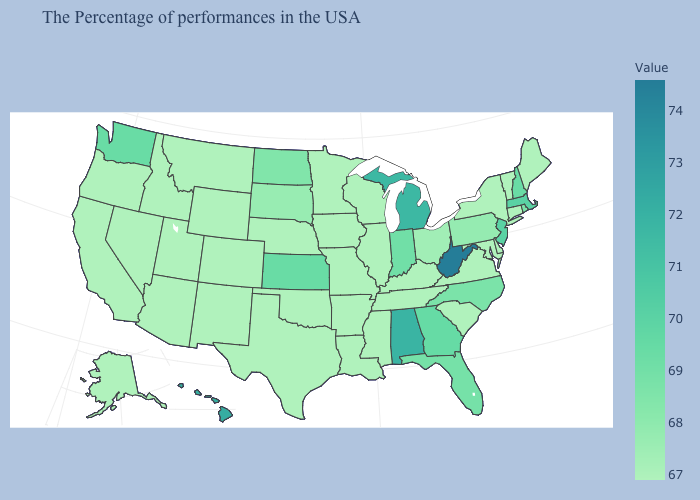Does the map have missing data?
Concise answer only. No. Among the states that border Minnesota , which have the highest value?
Write a very short answer. North Dakota. Among the states that border Indiana , which have the lowest value?
Write a very short answer. Kentucky, Illinois. Does Michigan have the lowest value in the USA?
Answer briefly. No. Does West Virginia have the highest value in the USA?
Short answer required. Yes. 